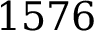Convert formula to latex. <formula><loc_0><loc_0><loc_500><loc_500>1 5 7 6</formula> 